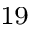Convert formula to latex. <formula><loc_0><loc_0><loc_500><loc_500>^ { 1 9 }</formula> 